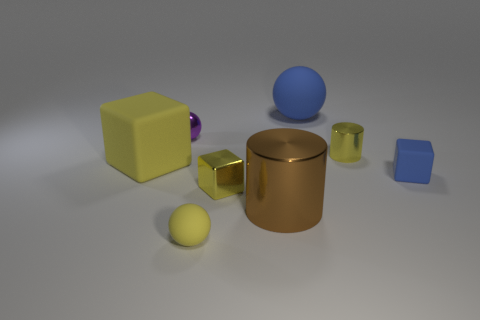Subtract all small rubber cubes. How many cubes are left? 2 Subtract all cyan cylinders. How many yellow cubes are left? 2 Add 2 large purple shiny spheres. How many objects exist? 10 Subtract 1 cubes. How many cubes are left? 2 Subtract all yellow balls. How many balls are left? 2 Subtract all cylinders. How many objects are left? 6 Subtract all large blue rubber balls. Subtract all brown metal cylinders. How many objects are left? 6 Add 5 blue objects. How many blue objects are left? 7 Add 1 small green metal things. How many small green metal things exist? 1 Subtract 0 gray spheres. How many objects are left? 8 